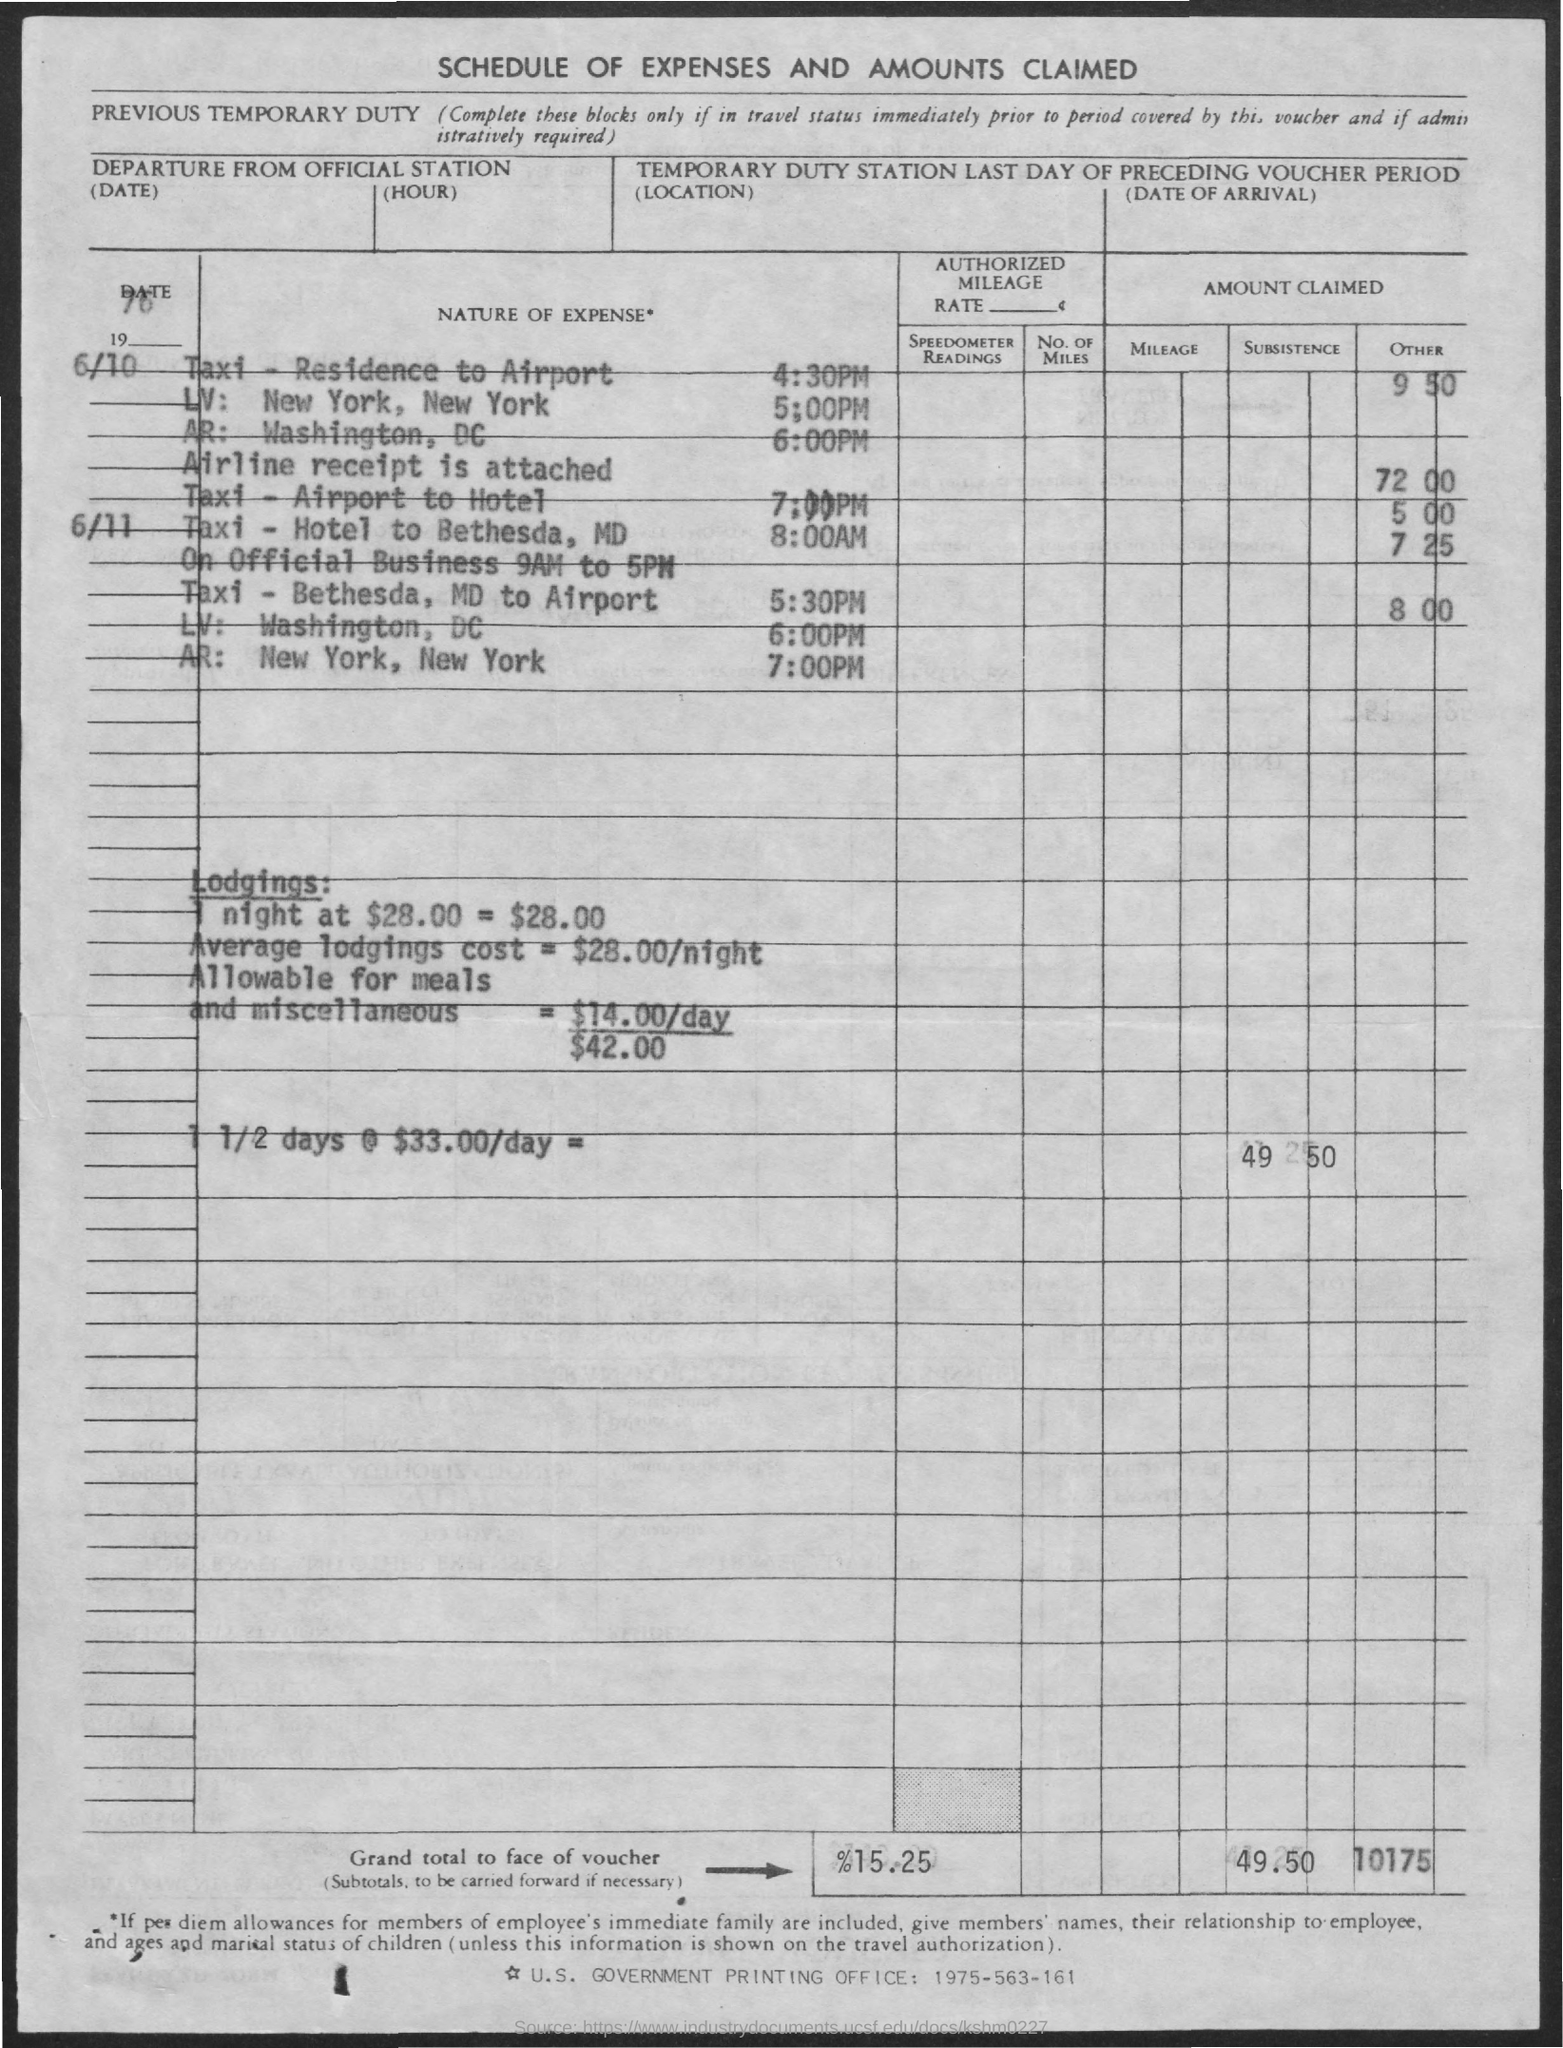What is the title?
Your answer should be compact. Schedule of expenses and amounts claimed. 